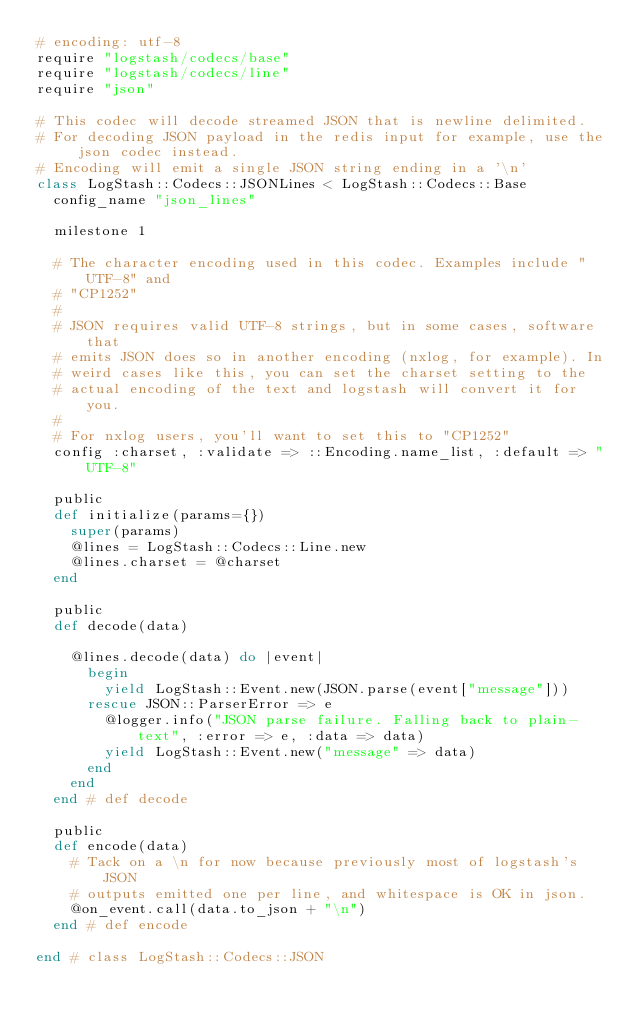<code> <loc_0><loc_0><loc_500><loc_500><_Ruby_># encoding: utf-8
require "logstash/codecs/base"
require "logstash/codecs/line"
require "json"

# This codec will decode streamed JSON that is newline delimited.
# For decoding JSON payload in the redis input for example, use the json codec instead.
# Encoding will emit a single JSON string ending in a '\n'
class LogStash::Codecs::JSONLines < LogStash::Codecs::Base
  config_name "json_lines"

  milestone 1

  # The character encoding used in this codec. Examples include "UTF-8" and
  # "CP1252"
  #
  # JSON requires valid UTF-8 strings, but in some cases, software that
  # emits JSON does so in another encoding (nxlog, for example). In
  # weird cases like this, you can set the charset setting to the
  # actual encoding of the text and logstash will convert it for you.
  #
  # For nxlog users, you'll want to set this to "CP1252"
  config :charset, :validate => ::Encoding.name_list, :default => "UTF-8"

  public
  def initialize(params={})
    super(params)
    @lines = LogStash::Codecs::Line.new
    @lines.charset = @charset
  end
  
  public
  def decode(data)

    @lines.decode(data) do |event|
      begin
        yield LogStash::Event.new(JSON.parse(event["message"]))
      rescue JSON::ParserError => e
        @logger.info("JSON parse failure. Falling back to plain-text", :error => e, :data => data)
        yield LogStash::Event.new("message" => data)
      end
    end
  end # def decode

  public
  def encode(data)
    # Tack on a \n for now because previously most of logstash's JSON
    # outputs emitted one per line, and whitespace is OK in json.
    @on_event.call(data.to_json + "\n")
  end # def encode

end # class LogStash::Codecs::JSON
</code> 